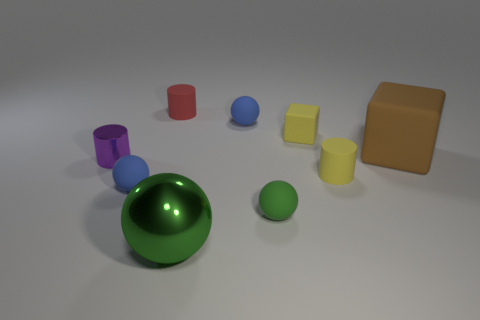Add 1 gray cubes. How many objects exist? 10 Subtract all cylinders. How many objects are left? 6 Subtract all yellow blocks. Subtract all big rubber balls. How many objects are left? 8 Add 6 large cubes. How many large cubes are left? 7 Add 3 red things. How many red things exist? 4 Subtract 0 brown cylinders. How many objects are left? 9 